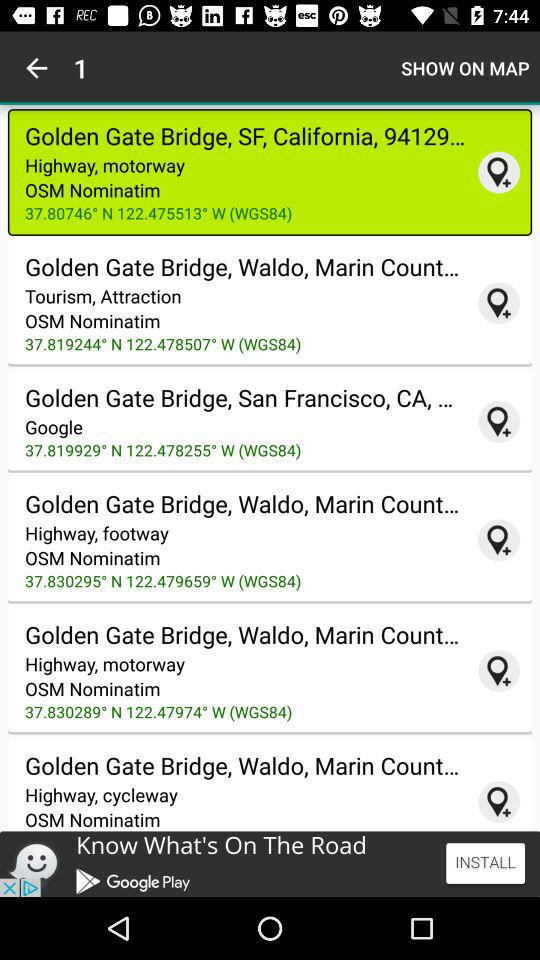Which address is selected? The selected address is "Golden Gate Bridge, SF, California, 94129...". 